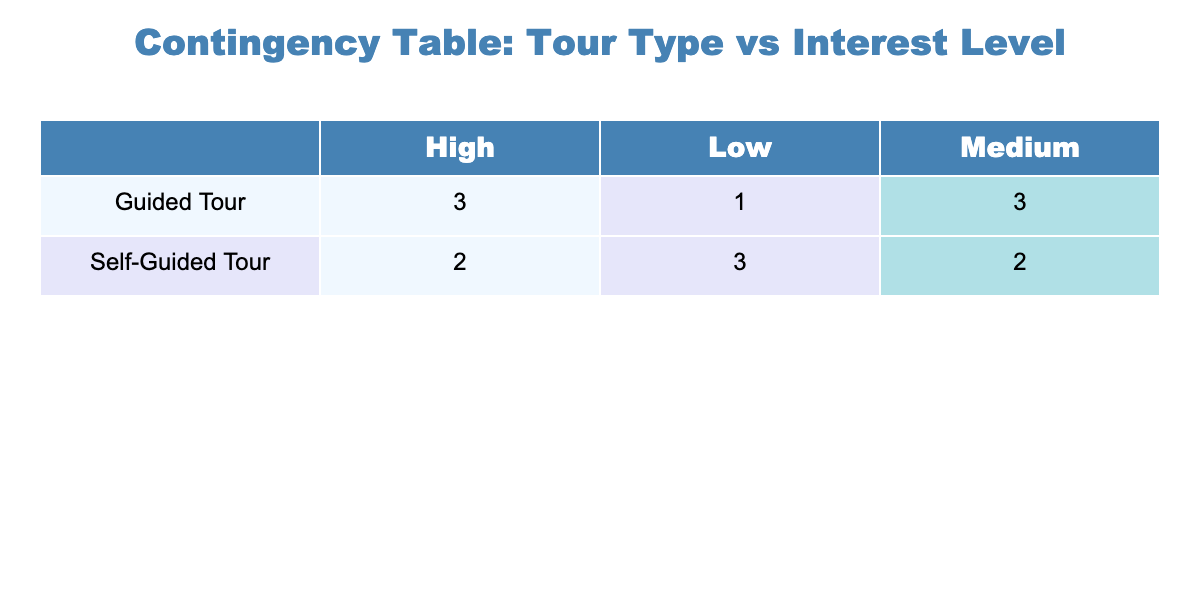What is the total number of students who reported a high interest level after a guided tour? Looking at the table, under the 'Guided Tour' row, the 'High' interest level column shows 4 entries. Therefore, the total would be 4.
Answer: 4 How many schools reported a medium interest level for self-guided tours? In the table, under the 'Self-Guided Tour' row, the 'Medium' interest level column has 1 entry. Thus, the answer is 1.
Answer: 1 Is there any school district with a low interest level for guided tours? Looking under the 'Guided Tour' row, the 'Low' interest level column does not show any entries, indicating there are no school districts with low interest levels for guided tours.
Answer: No What is the difference in the number of schools that reported high interest levels between guided and self-guided tours? For 'Guided Tour', there are 4 schools with high interest. For 'Self-Guided Tour', there is 1 school with high interest. The difference is 4 - 1 = 3.
Answer: 3 Which tour type has a higher number of medium interest levels reported? By examining the medium interest levels, for 'Guided Tour', there are 5 entries and for 'Self-Guided Tour', there are 3 entries. With more entries in the Guided Tour (5), it indicates that this type has higher medium interest levels.
Answer: Guided Tour What is the total number of students with a low interest level across both tour types? For 'Guided Tour', the 'Low' interest level shows 0 entries, while for 'Self-Guided Tour', it shows 3 entries. Therefore, the total for both types is 0 + 3 = 3.
Answer: 3 Do more school districts have high interest levels towards guided tours or self-guided tours? Under high interest levels, the 'Guided Tour' has 4 districts, while the 'Self-Guided Tour' has 1 district. Hence, there are more districts interested in guided tours.
Answer: Guided Tours What is the average number of interest levels (high, medium, low) for guided tours? The guided tours have 4 high, 5 medium, and 0 low interest levels, summing these gives 4 + 5 + 0 = 9. Dividing by the three interest categories results in an average of 9 / 3 = 3.
Answer: 3 